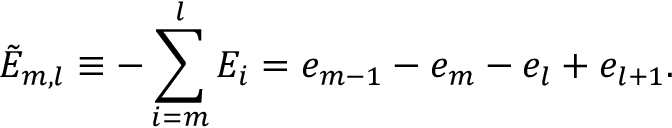Convert formula to latex. <formula><loc_0><loc_0><loc_500><loc_500>\tilde { E } _ { m , l } \equiv - \sum _ { i = m } ^ { l } E _ { i } = e _ { m - 1 } - e _ { m } - e _ { l } + e _ { l + 1 } .</formula> 